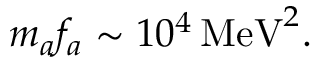<formula> <loc_0><loc_0><loc_500><loc_500>m _ { a } f _ { a } \sim 1 0 ^ { 4 } \, M e V ^ { 2 } .</formula> 